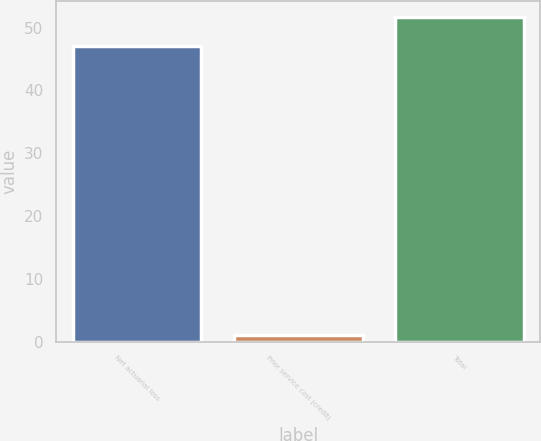Convert chart to OTSL. <chart><loc_0><loc_0><loc_500><loc_500><bar_chart><fcel>Net actuarial loss<fcel>Prior service cost (credit)<fcel>Total<nl><fcel>47<fcel>1<fcel>51.7<nl></chart> 